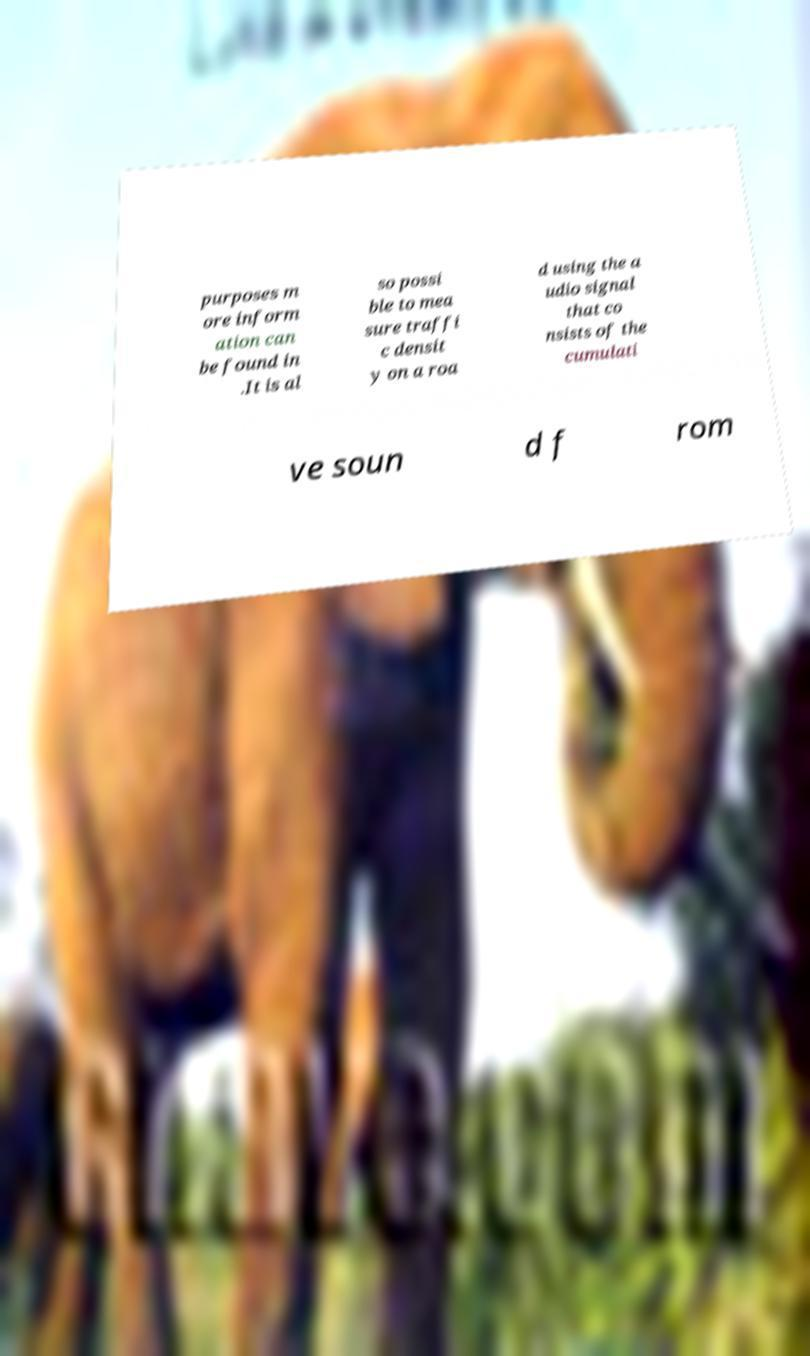There's text embedded in this image that I need extracted. Can you transcribe it verbatim? purposes m ore inform ation can be found in .It is al so possi ble to mea sure traffi c densit y on a roa d using the a udio signal that co nsists of the cumulati ve soun d f rom 